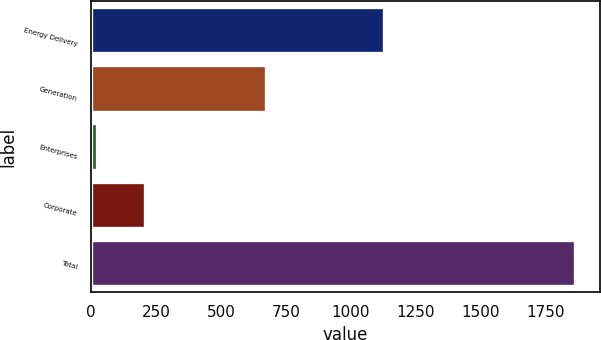Convert chart to OTSL. <chart><loc_0><loc_0><loc_500><loc_500><bar_chart><fcel>Energy Delivery<fcel>Generation<fcel>Enterprises<fcel>Corporate<fcel>Total<nl><fcel>1128<fcel>673<fcel>22<fcel>206.2<fcel>1864<nl></chart> 